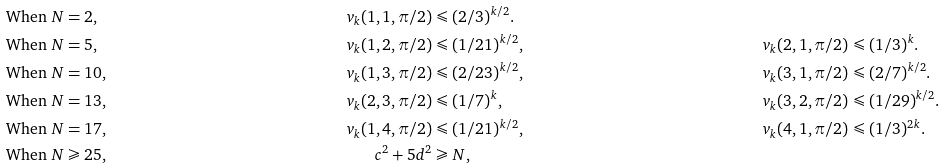<formula> <loc_0><loc_0><loc_500><loc_500>& \text {When $N = 2$,} & v _ { k } ( 1 , 1 , \pi / 2 ) & \leqslant ( 2 / 3 ) ^ { k / 2 } . \\ & \text {When $N = 5$,} & v _ { k } ( 1 , 2 , \pi / 2 ) & \leqslant ( 1 / 2 1 ) ^ { k / 2 } , & v _ { k } ( 2 , 1 , \pi / 2 ) & \leqslant ( 1 / 3 ) ^ { k } . \\ & \text {When $N = 10$,} & v _ { k } ( 1 , 3 , \pi / 2 ) & \leqslant ( 2 / 2 3 ) ^ { k / 2 } , & v _ { k } ( 3 , 1 , \pi / 2 ) & \leqslant ( 2 / 7 ) ^ { k / 2 } . \\ & \text {When $N = 13$,} & v _ { k } ( 2 , 3 , \pi / 2 ) & \leqslant ( 1 / 7 ) ^ { k } , & v _ { k } ( 3 , 2 , \pi / 2 ) & \leqslant ( 1 / 2 9 ) ^ { k / 2 } . \\ & \text {When $N = 17$,} & v _ { k } ( 1 , 4 , \pi / 2 ) & \leqslant ( 1 / 2 1 ) ^ { k / 2 } , & v _ { k } ( 4 , 1 , \pi / 2 ) & \leqslant ( 1 / 3 ) ^ { 2 k } . \\ & \text {When $N \geqslant 25$,} & c ^ { 2 } + 5 d ^ { 2 } & \geqslant N ,</formula> 